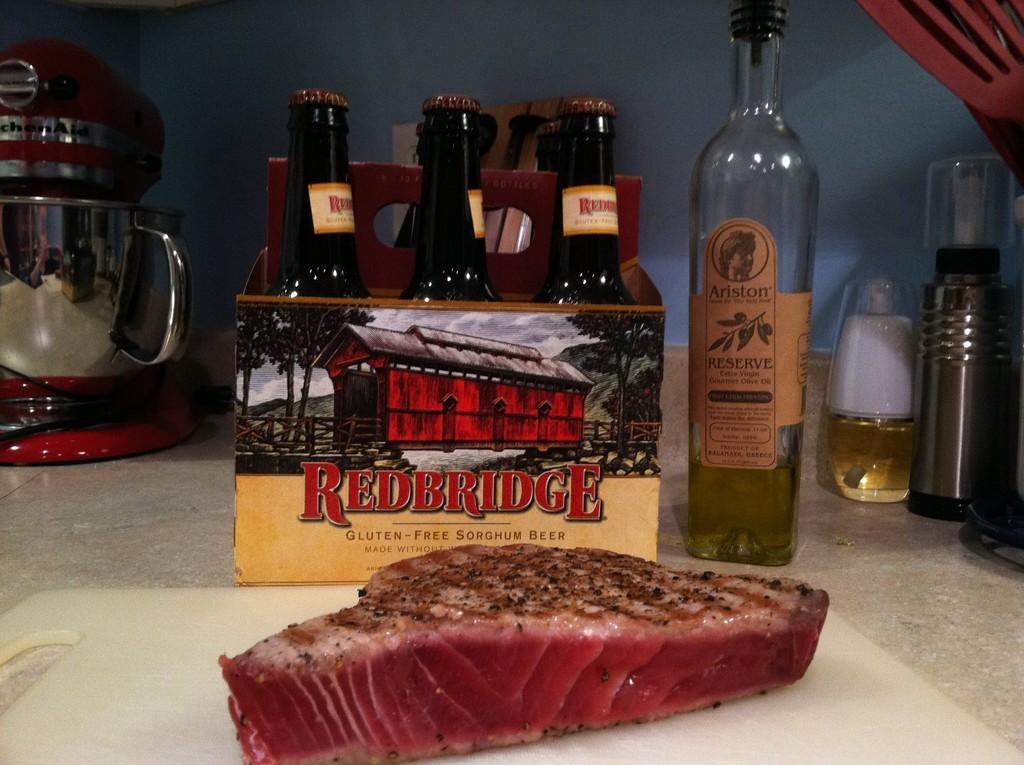<image>
Provide a brief description of the given image. A six pack of Rederidge Gluten-Free Sorghum Beer on a table with a bottle of Ariston and a piece of meat. 